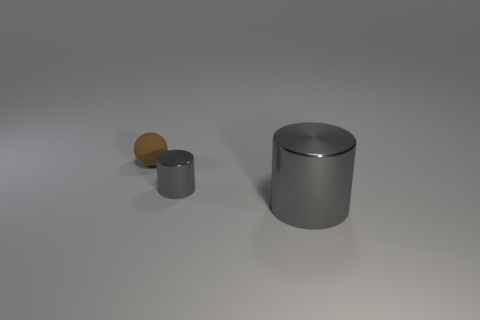Add 3 big cyan matte objects. How many objects exist? 6 Subtract all cylinders. How many objects are left? 1 Add 1 small brown objects. How many small brown objects are left? 2 Add 2 big gray shiny cylinders. How many big gray shiny cylinders exist? 3 Subtract 0 green blocks. How many objects are left? 3 Subtract all tiny rubber objects. Subtract all big gray objects. How many objects are left? 1 